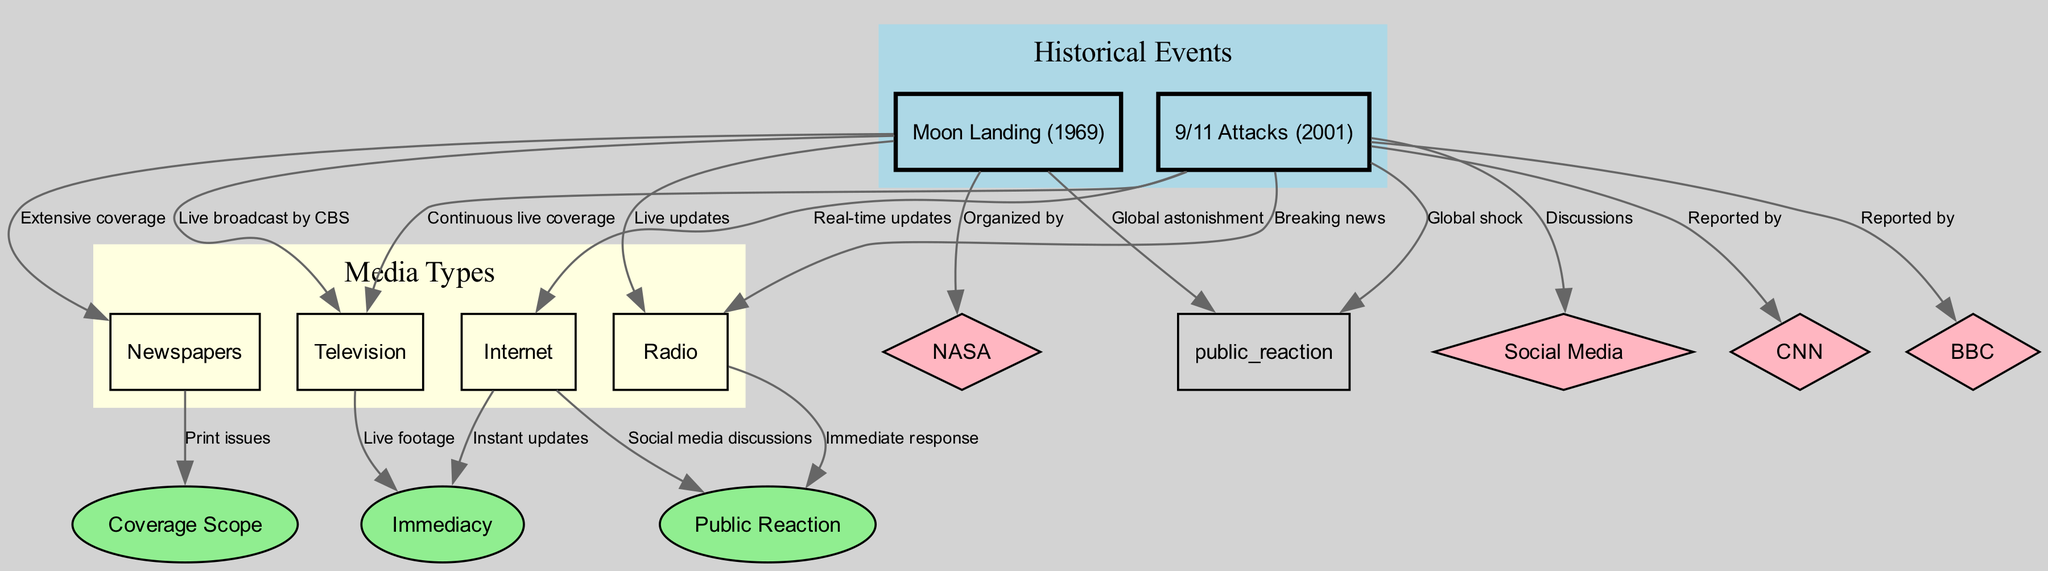What event had extensive media coverage from newspapers? According to the diagram, the Moon Landing event is linked with the media type of Newspapers with the label "Extensive coverage." This direct connection indicates that the Moon Landing received significant attention in print media.
Answer: Moon Landing Which media type provided continuous live coverage during the 9/11 attacks? The diagram shows a direct connection from the 9/11 Attacks event to the media type of Television with the label "Continuous live coverage." This indicates that Television played a major role in delivering real-time news during the attacks.
Answer: Television How many media types are represented in the diagram? The diagram lists four distinct media types: Newspapers, Television, Radio, and Internet. Counting these nodes confirms that there are a total of four media types represented.
Answer: 4 What was the public reaction to the Moon Landing? The diagram connects the Moon Landing event to the aspect of Public Reaction, labeled "Global astonishment." This indicates that the public response to the event was one of widespread amazement and wonder.
Answer: Global astonishment Which entity reported extensively on the 9/11 attacks? There are direct connections from the 9/11 event to multiple entities: CNN and BBC, both labeled "Reported by." These connections illustrate that both news organizations were involved in covering the events of that day.
Answer: CNN and BBC What aspect is associated with immediate response in radio media? The edge connecting Radio media to the Public Reaction aspect is labeled "Immediate response." This shows that Radio provided a platform for swift reactions to the events as they unfolded.
Answer: Immediate response How did the Internet provide information during the 9/11 attacks? The Internet is connected to the 9/11 Attacks with the label "Real-time updates." This connection indicates that the Internet was a key source for instant information about the tragic events as they happened.
Answer: Real-time updates Which event was organized by NASA? The diagram illustrates a connection from the Moon Landing event to the entity NASA with the label "Organized by." This signifies that NASA was responsible for arranging the Moon Landing itself.
Answer: NASA What type of media gave live updates during the Moon Landing? The diagram depicts a direct relationship from the Moon Landing event to Radio media with the label "Live updates." This indicates that Radio played a significant role in broadcasting updates at the time of the Moon Landing.
Answer: Radio 